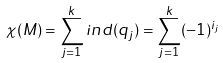<formula> <loc_0><loc_0><loc_500><loc_500>\chi ( M ) = \sum _ { j = 1 } ^ { k } i n d ( q _ { j } ) = \sum _ { j = 1 } ^ { k } ( - 1 ) ^ { i _ { j } }</formula> 